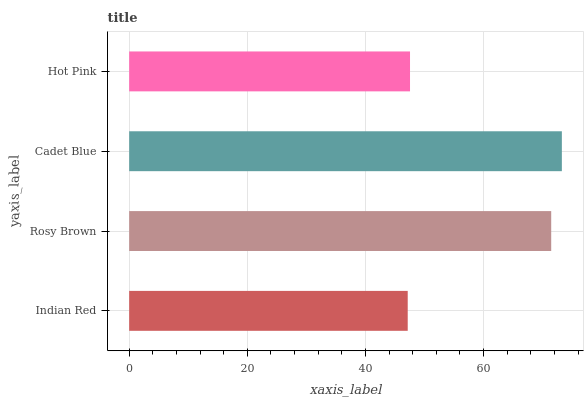Is Indian Red the minimum?
Answer yes or no. Yes. Is Cadet Blue the maximum?
Answer yes or no. Yes. Is Rosy Brown the minimum?
Answer yes or no. No. Is Rosy Brown the maximum?
Answer yes or no. No. Is Rosy Brown greater than Indian Red?
Answer yes or no. Yes. Is Indian Red less than Rosy Brown?
Answer yes or no. Yes. Is Indian Red greater than Rosy Brown?
Answer yes or no. No. Is Rosy Brown less than Indian Red?
Answer yes or no. No. Is Rosy Brown the high median?
Answer yes or no. Yes. Is Hot Pink the low median?
Answer yes or no. Yes. Is Indian Red the high median?
Answer yes or no. No. Is Indian Red the low median?
Answer yes or no. No. 